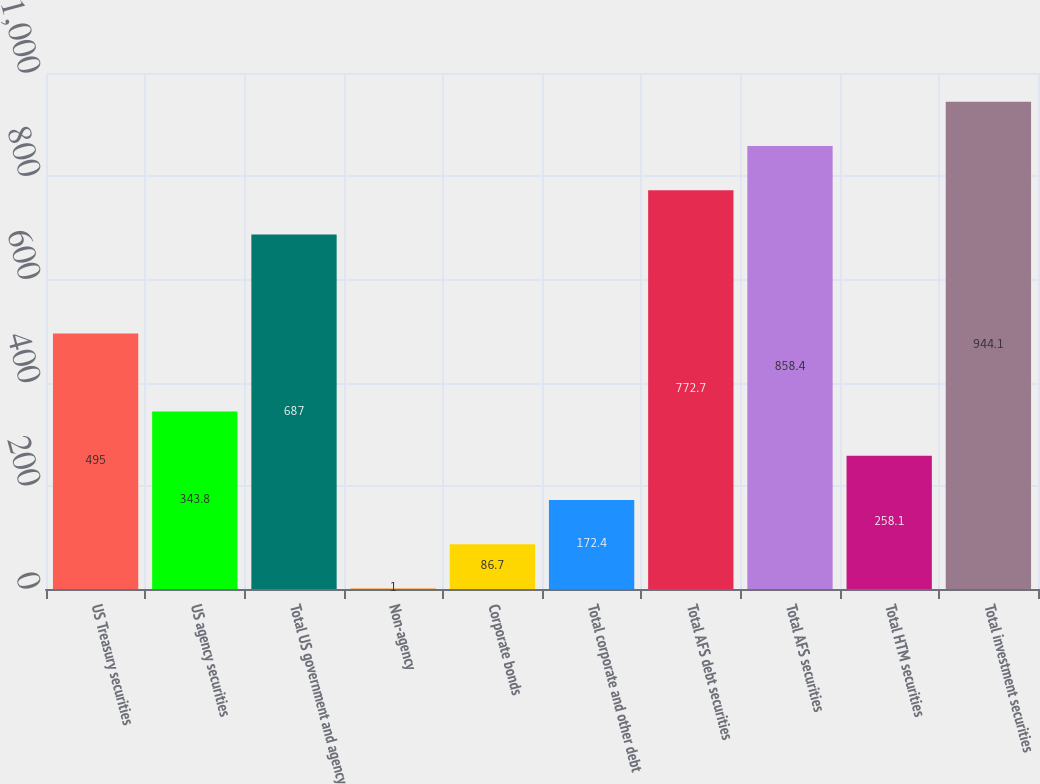Convert chart. <chart><loc_0><loc_0><loc_500><loc_500><bar_chart><fcel>US Treasury securities<fcel>US agency securities<fcel>Total US government and agency<fcel>Non-agency<fcel>Corporate bonds<fcel>Total corporate and other debt<fcel>Total AFS debt securities<fcel>Total AFS securities<fcel>Total HTM securities<fcel>Total investment securities<nl><fcel>495<fcel>343.8<fcel>687<fcel>1<fcel>86.7<fcel>172.4<fcel>772.7<fcel>858.4<fcel>258.1<fcel>944.1<nl></chart> 